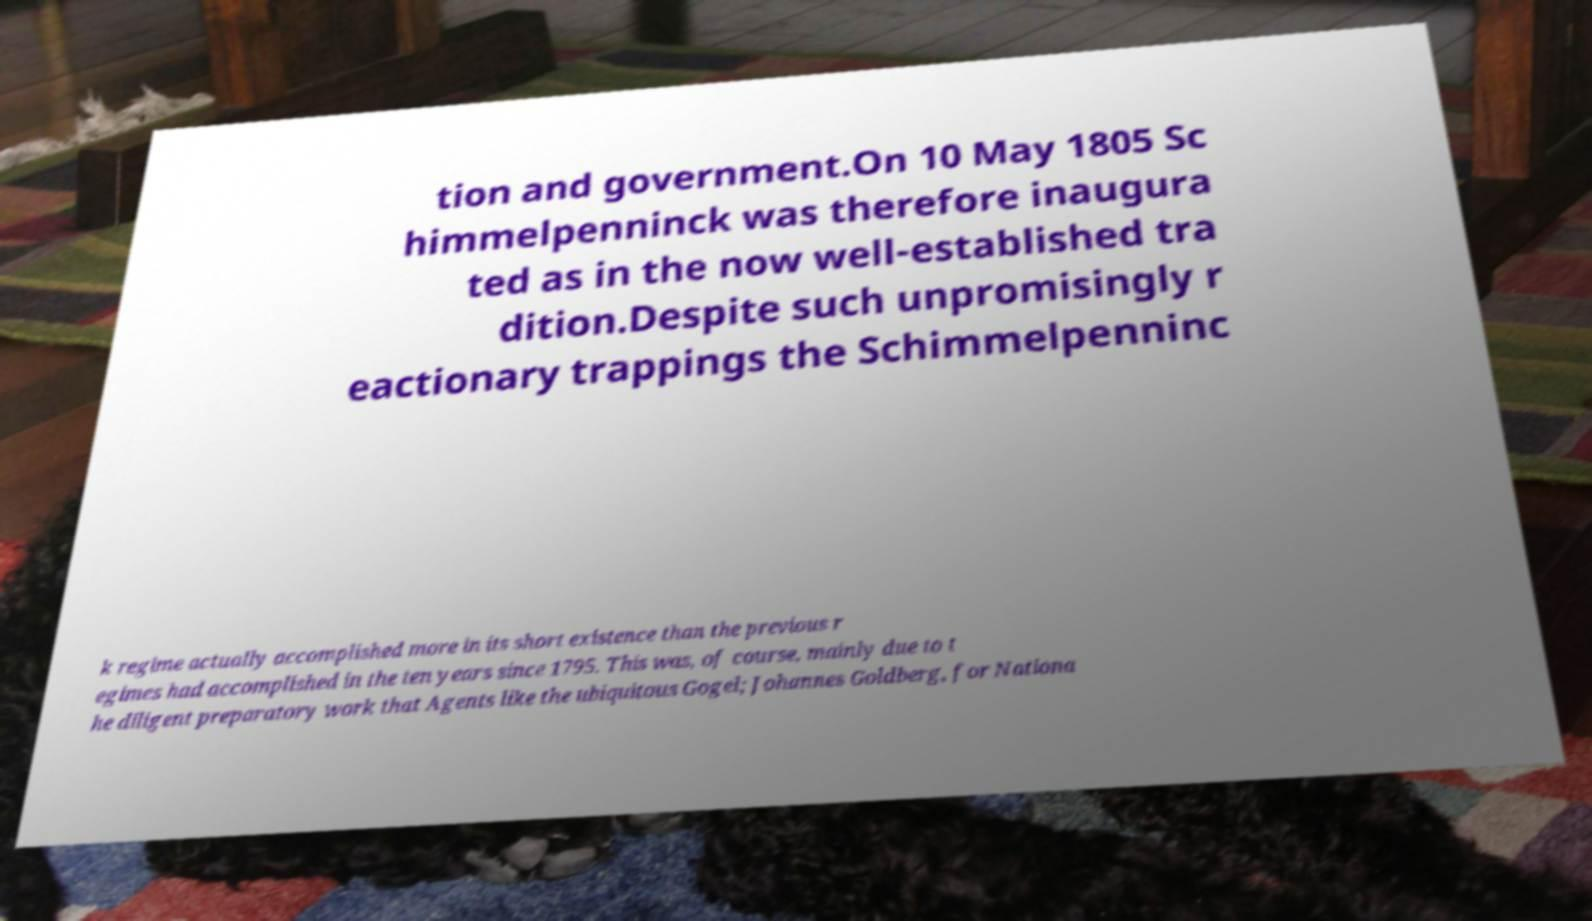Could you extract and type out the text from this image? tion and government.On 10 May 1805 Sc himmelpenninck was therefore inaugura ted as in the now well-established tra dition.Despite such unpromisingly r eactionary trappings the Schimmelpenninc k regime actually accomplished more in its short existence than the previous r egimes had accomplished in the ten years since 1795. This was, of course, mainly due to t he diligent preparatory work that Agents like the ubiquitous Gogel; Johannes Goldberg, for Nationa 